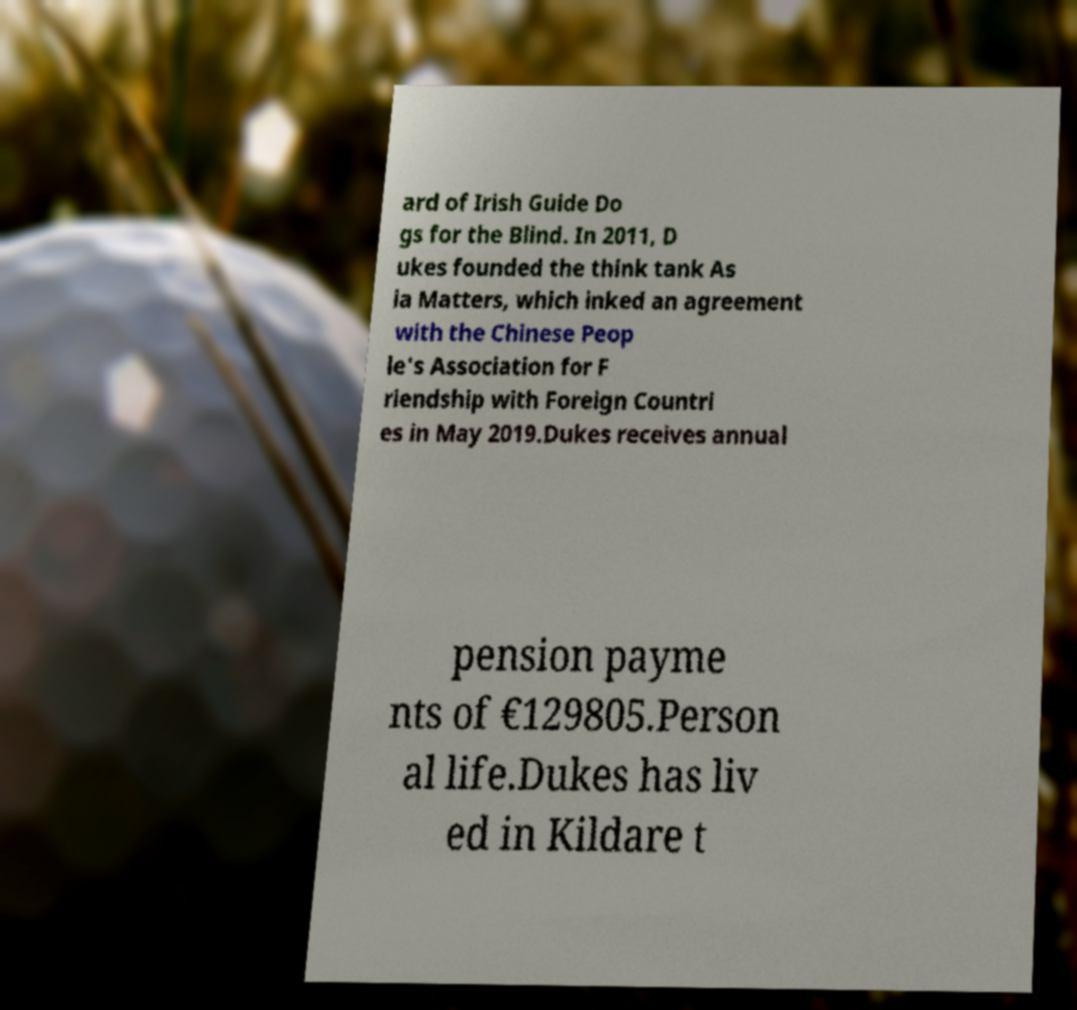For documentation purposes, I need the text within this image transcribed. Could you provide that? ard of Irish Guide Do gs for the Blind. In 2011, D ukes founded the think tank As ia Matters, which inked an agreement with the Chinese Peop le's Association for F riendship with Foreign Countri es in May 2019.Dukes receives annual pension payme nts of €129805.Person al life.Dukes has liv ed in Kildare t 